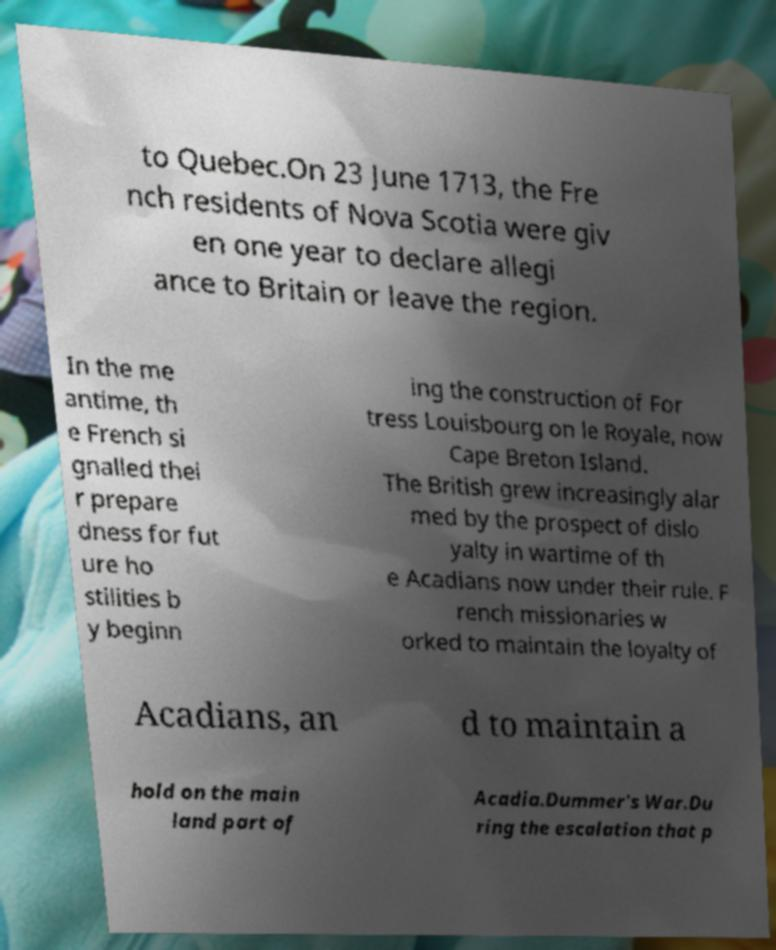I need the written content from this picture converted into text. Can you do that? to Quebec.On 23 June 1713, the Fre nch residents of Nova Scotia were giv en one year to declare allegi ance to Britain or leave the region. In the me antime, th e French si gnalled thei r prepare dness for fut ure ho stilities b y beginn ing the construction of For tress Louisbourg on le Royale, now Cape Breton Island. The British grew increasingly alar med by the prospect of dislo yalty in wartime of th e Acadians now under their rule. F rench missionaries w orked to maintain the loyalty of Acadians, an d to maintain a hold on the main land part of Acadia.Dummer's War.Du ring the escalation that p 